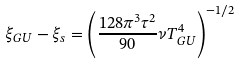Convert formula to latex. <formula><loc_0><loc_0><loc_500><loc_500>\xi _ { G U } - \xi _ { s } = \left ( \frac { 1 2 8 \pi ^ { 3 } \tau ^ { 2 } } { 9 0 } \nu T ^ { 4 } _ { G U } \right ) ^ { - 1 / 2 }</formula> 